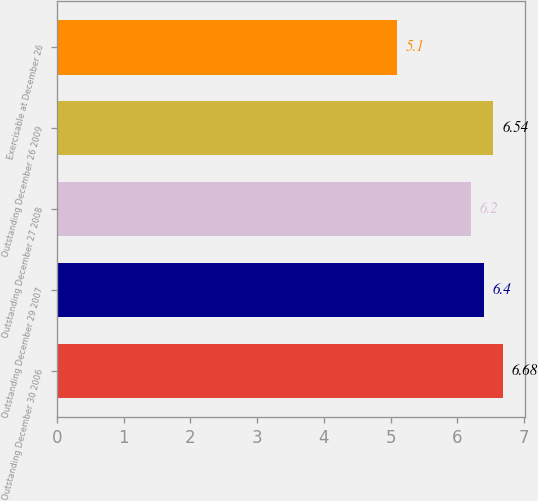Convert chart to OTSL. <chart><loc_0><loc_0><loc_500><loc_500><bar_chart><fcel>Outstanding December 30 2006<fcel>Outstanding December 29 2007<fcel>Outstanding December 27 2008<fcel>Outstanding December 26 2009<fcel>Exercisable at December 26<nl><fcel>6.68<fcel>6.4<fcel>6.2<fcel>6.54<fcel>5.1<nl></chart> 